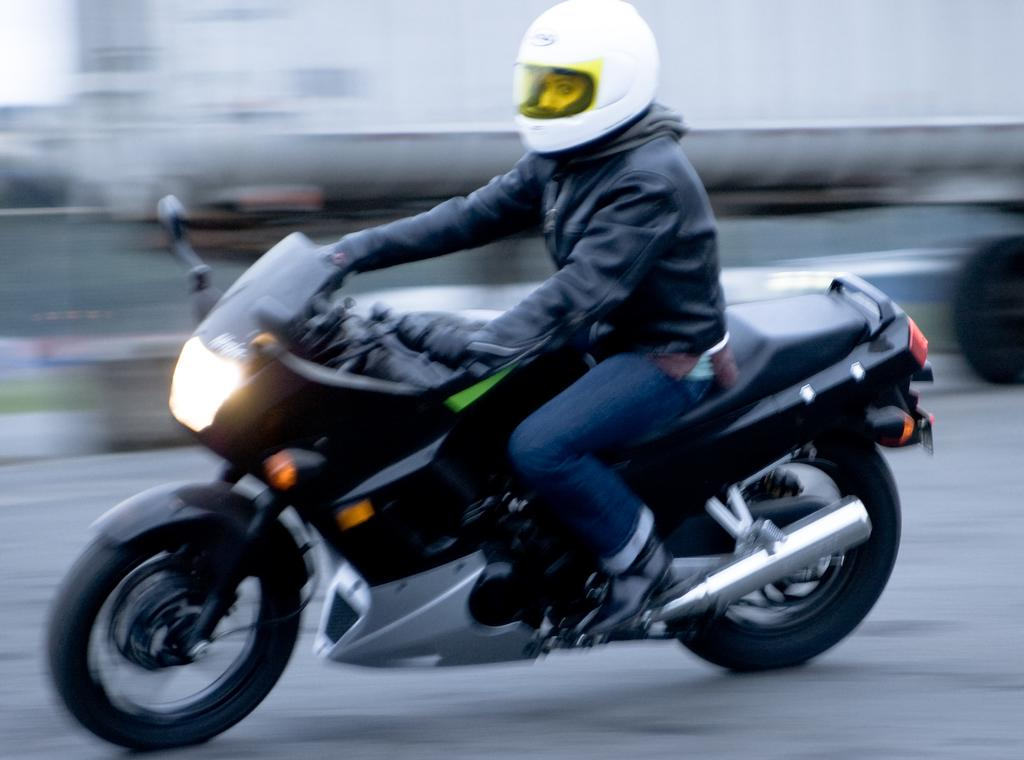Who or what is the main subject in the image? There is a person in the image. What protective gear is the person wearing? The person is wearing a helmet and gloves. What mode of transportation is the person using? The person is riding a motorcycle. How would you describe the background of the image? The background of the image is blurry. What type of destruction can be seen in the image? There is no destruction present in the image; it features a person riding a motorcycle with a blurry background. Can you identify any coils or iron elements in the image? There are no coils or iron elements visible in the image. 